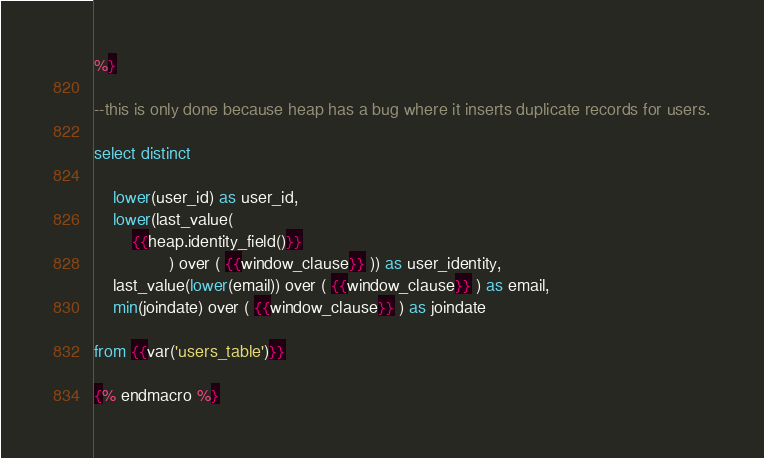<code> <loc_0><loc_0><loc_500><loc_500><_SQL_>%}

--this is only done because heap has a bug where it inserts duplicate records for users.

select distinct

    lower(user_id) as user_id,
    lower(last_value(
        {{heap.identity_field()}}
                ) over ( {{window_clause}} )) as user_identity,
    last_value(lower(email)) over ( {{window_clause}} ) as email,
    min(joindate) over ( {{window_clause}} ) as joindate
    
from {{var('users_table')}}

{% endmacro %}</code> 